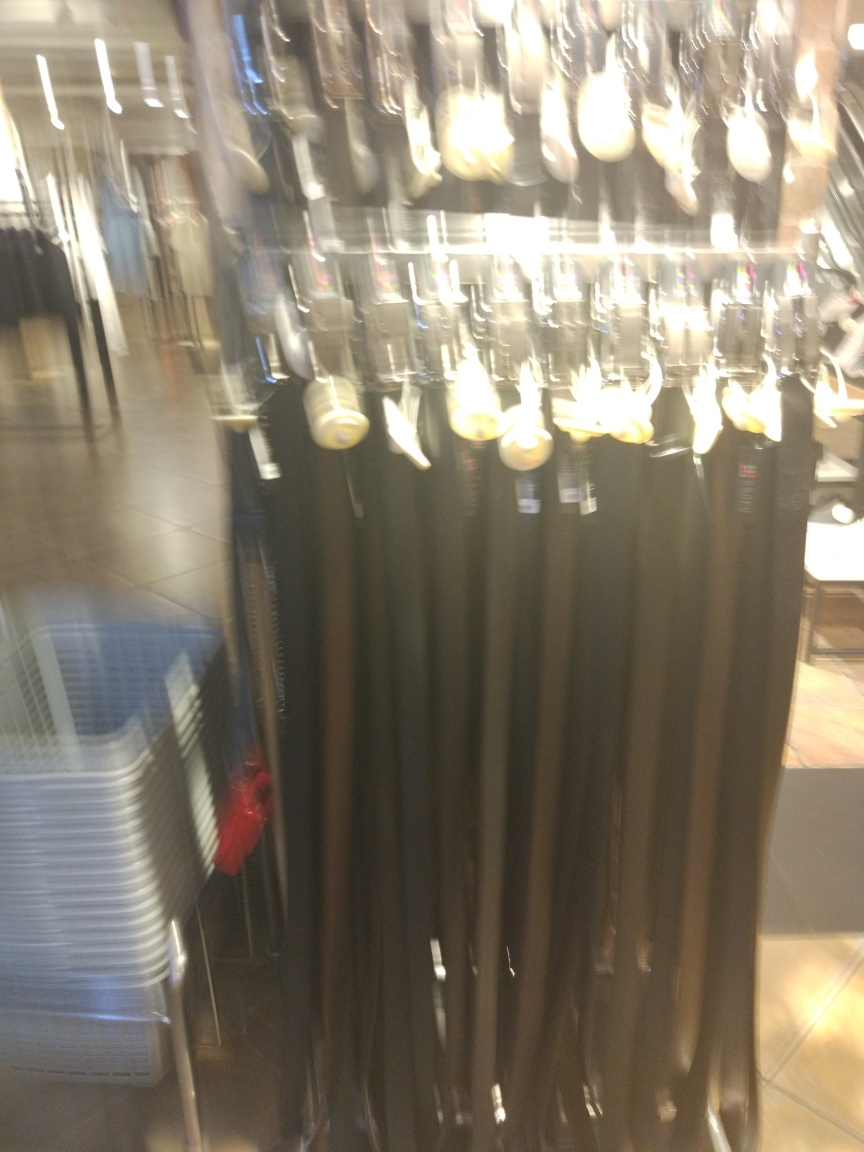Are there any quality issues with this image? Yes, the image has significant blurring which affects the clarity and detail, making it difficult to discern specific features of the items displayed. It appears to be a result of camera motion during the shot, a common issue when the camera is not held steady. Additionally, the lighting conditions and composition could be improved for better visual quality. 